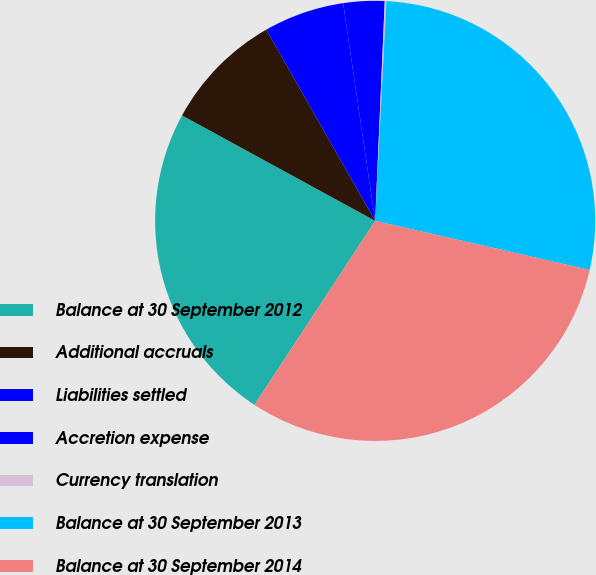Convert chart to OTSL. <chart><loc_0><loc_0><loc_500><loc_500><pie_chart><fcel>Balance at 30 September 2012<fcel>Additional accruals<fcel>Liabilities settled<fcel>Accretion expense<fcel>Currency translation<fcel>Balance at 30 September 2013<fcel>Balance at 30 September 2014<nl><fcel>23.72%<fcel>8.81%<fcel>5.91%<fcel>3.02%<fcel>0.12%<fcel>27.77%<fcel>30.66%<nl></chart> 